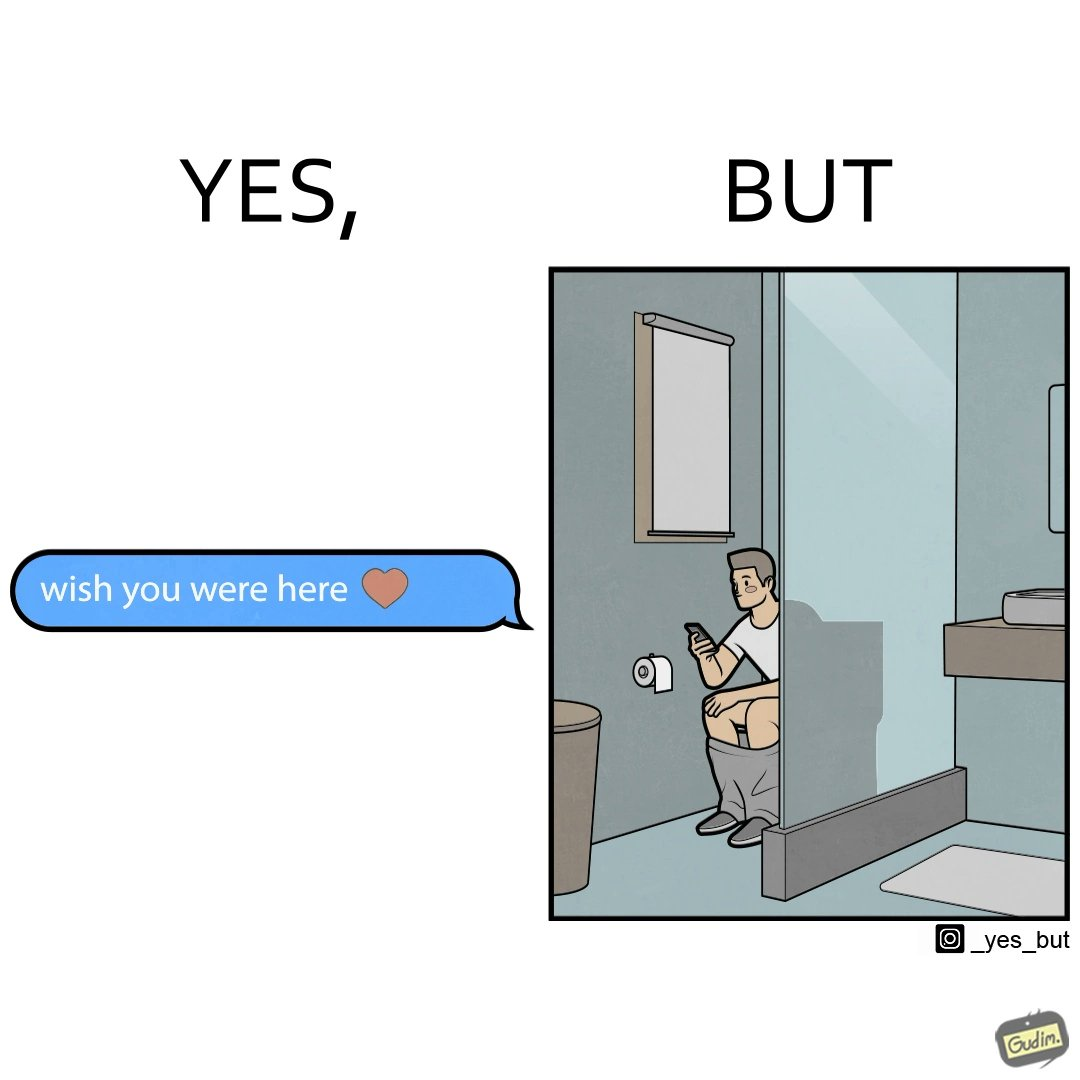Describe the contrast between the left and right parts of this image. In the left part of the image: It is a text saying "i wish you were here" indicating that someone is missing their partner In the right part of the image: It is a man using his phone while using a toilet 